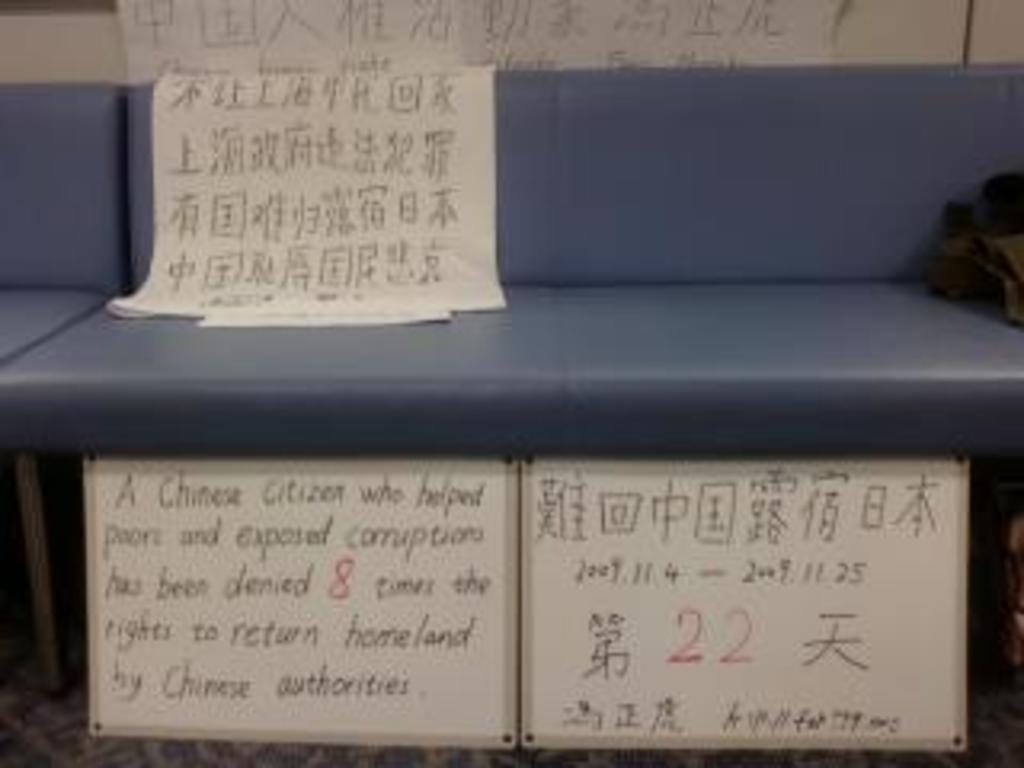How would you summarize this image in a sentence or two? In the foreground of this image, there are papers, boards and a leather seat like an object. On the right, there is a black object. 